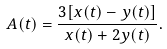<formula> <loc_0><loc_0><loc_500><loc_500>A ( t ) = \frac { 3 [ x ( t ) - y ( t ) ] } { x ( t ) + 2 y ( t ) } .</formula> 